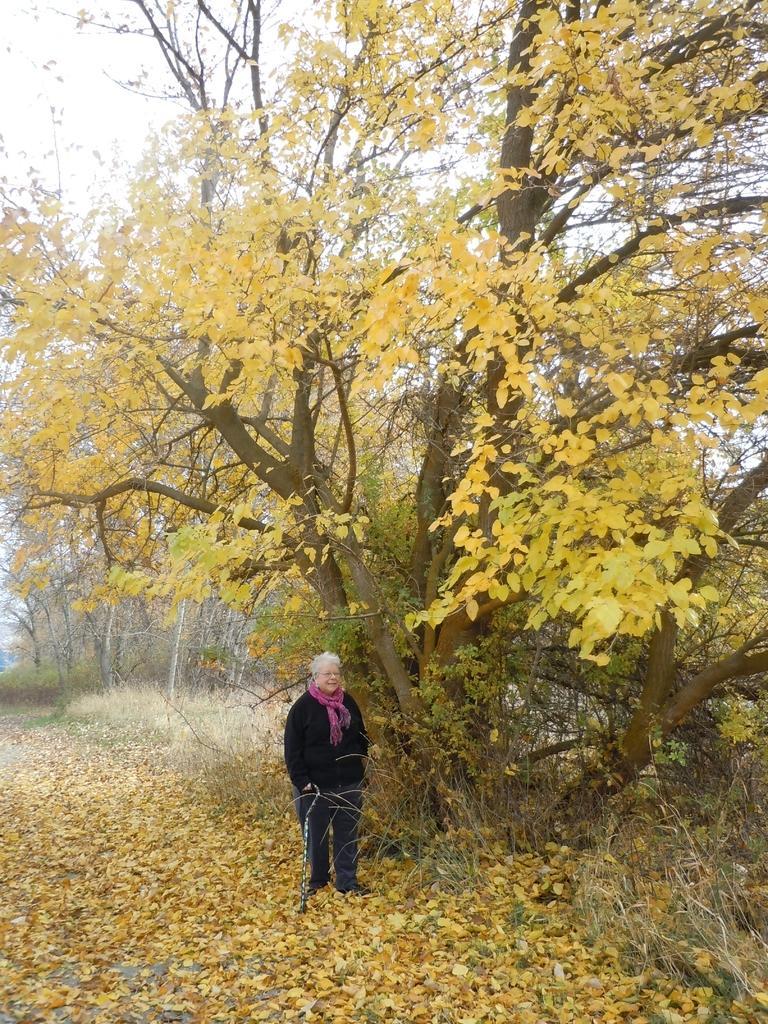Describe this image in one or two sentences. In this image, we can see a person wearing clothes and standing in front of the tree. There are some dry leaves on the ground. 